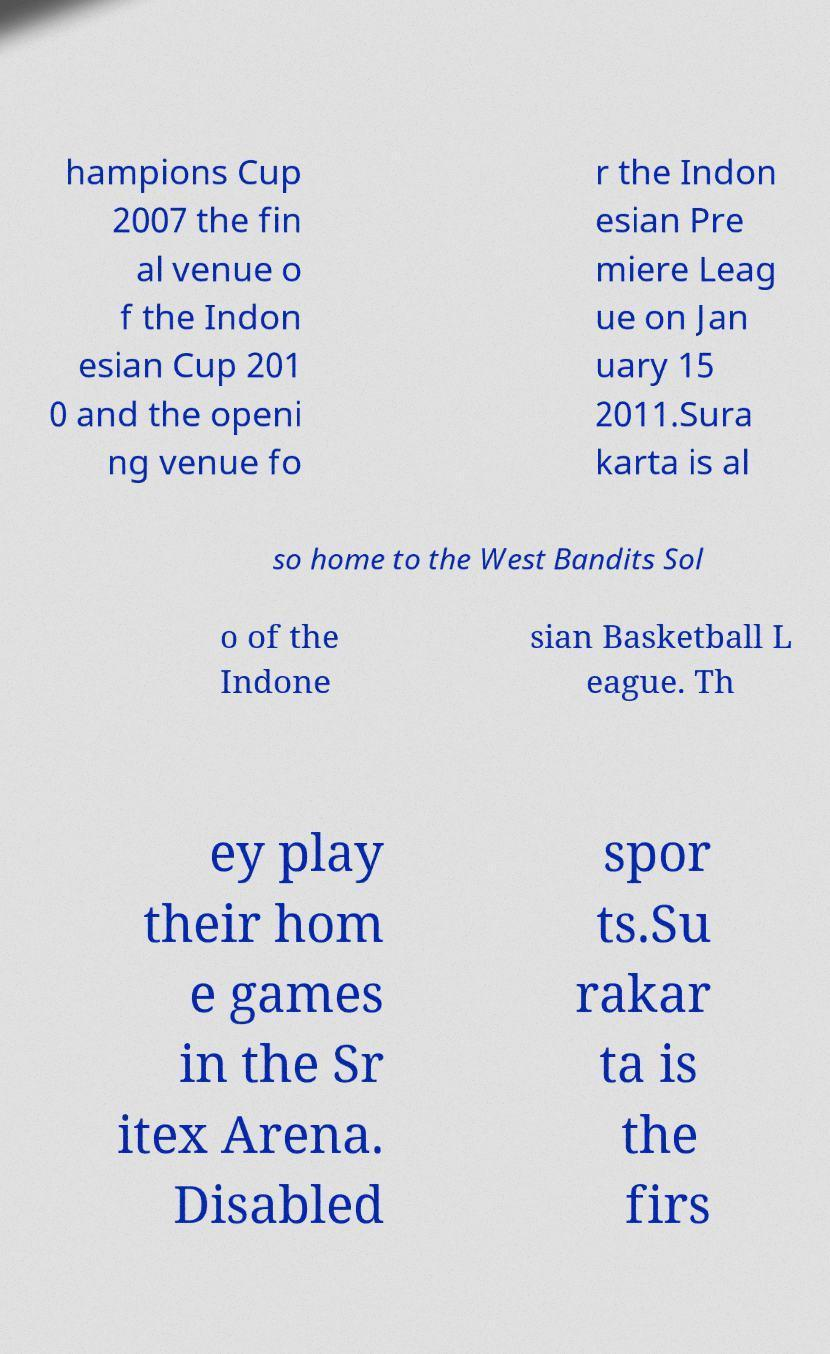For documentation purposes, I need the text within this image transcribed. Could you provide that? hampions Cup 2007 the fin al venue o f the Indon esian Cup 201 0 and the openi ng venue fo r the Indon esian Pre miere Leag ue on Jan uary 15 2011.Sura karta is al so home to the West Bandits Sol o of the Indone sian Basketball L eague. Th ey play their hom e games in the Sr itex Arena. Disabled spor ts.Su rakar ta is the firs 